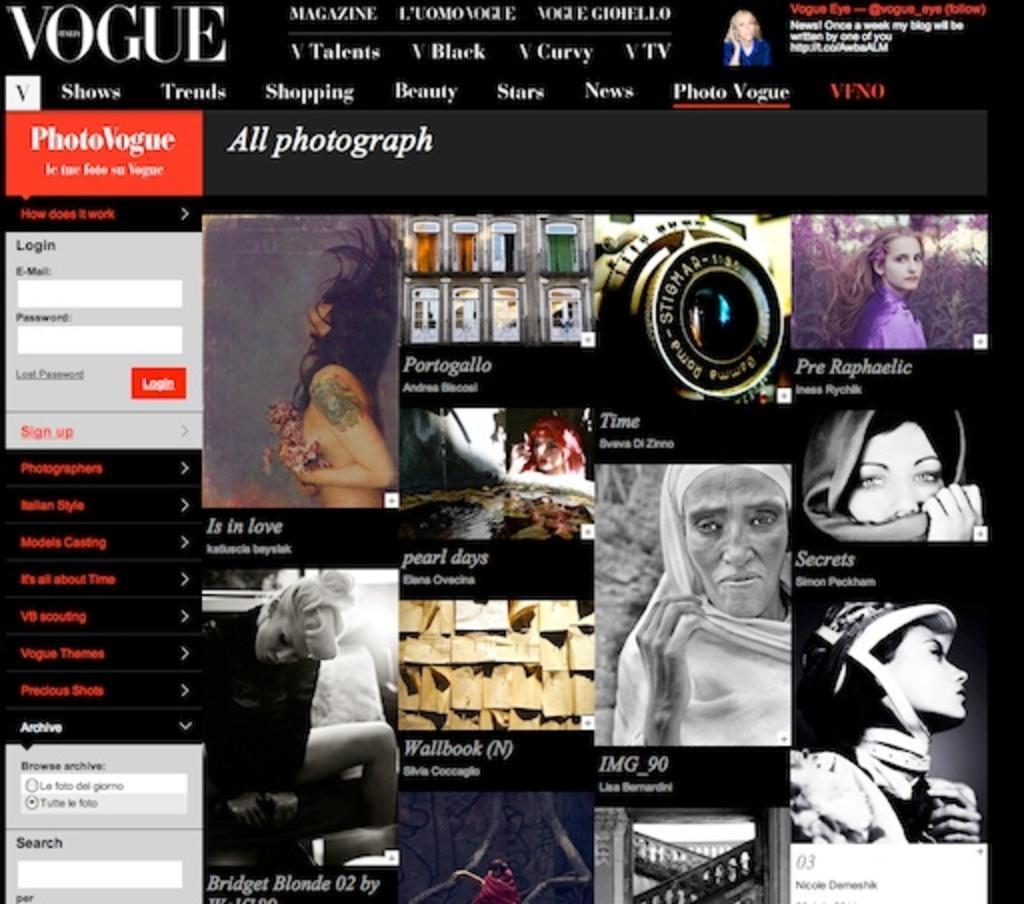What is the main subject of the image? There is a picture of a website in the image. What can be seen within the picture of the website? There are people visible in the picture of the website, as well as a ladder and text. What type of underwear is the person wearing in the image? There is no person wearing underwear in the image, as the people are depicted within the picture of the website. 